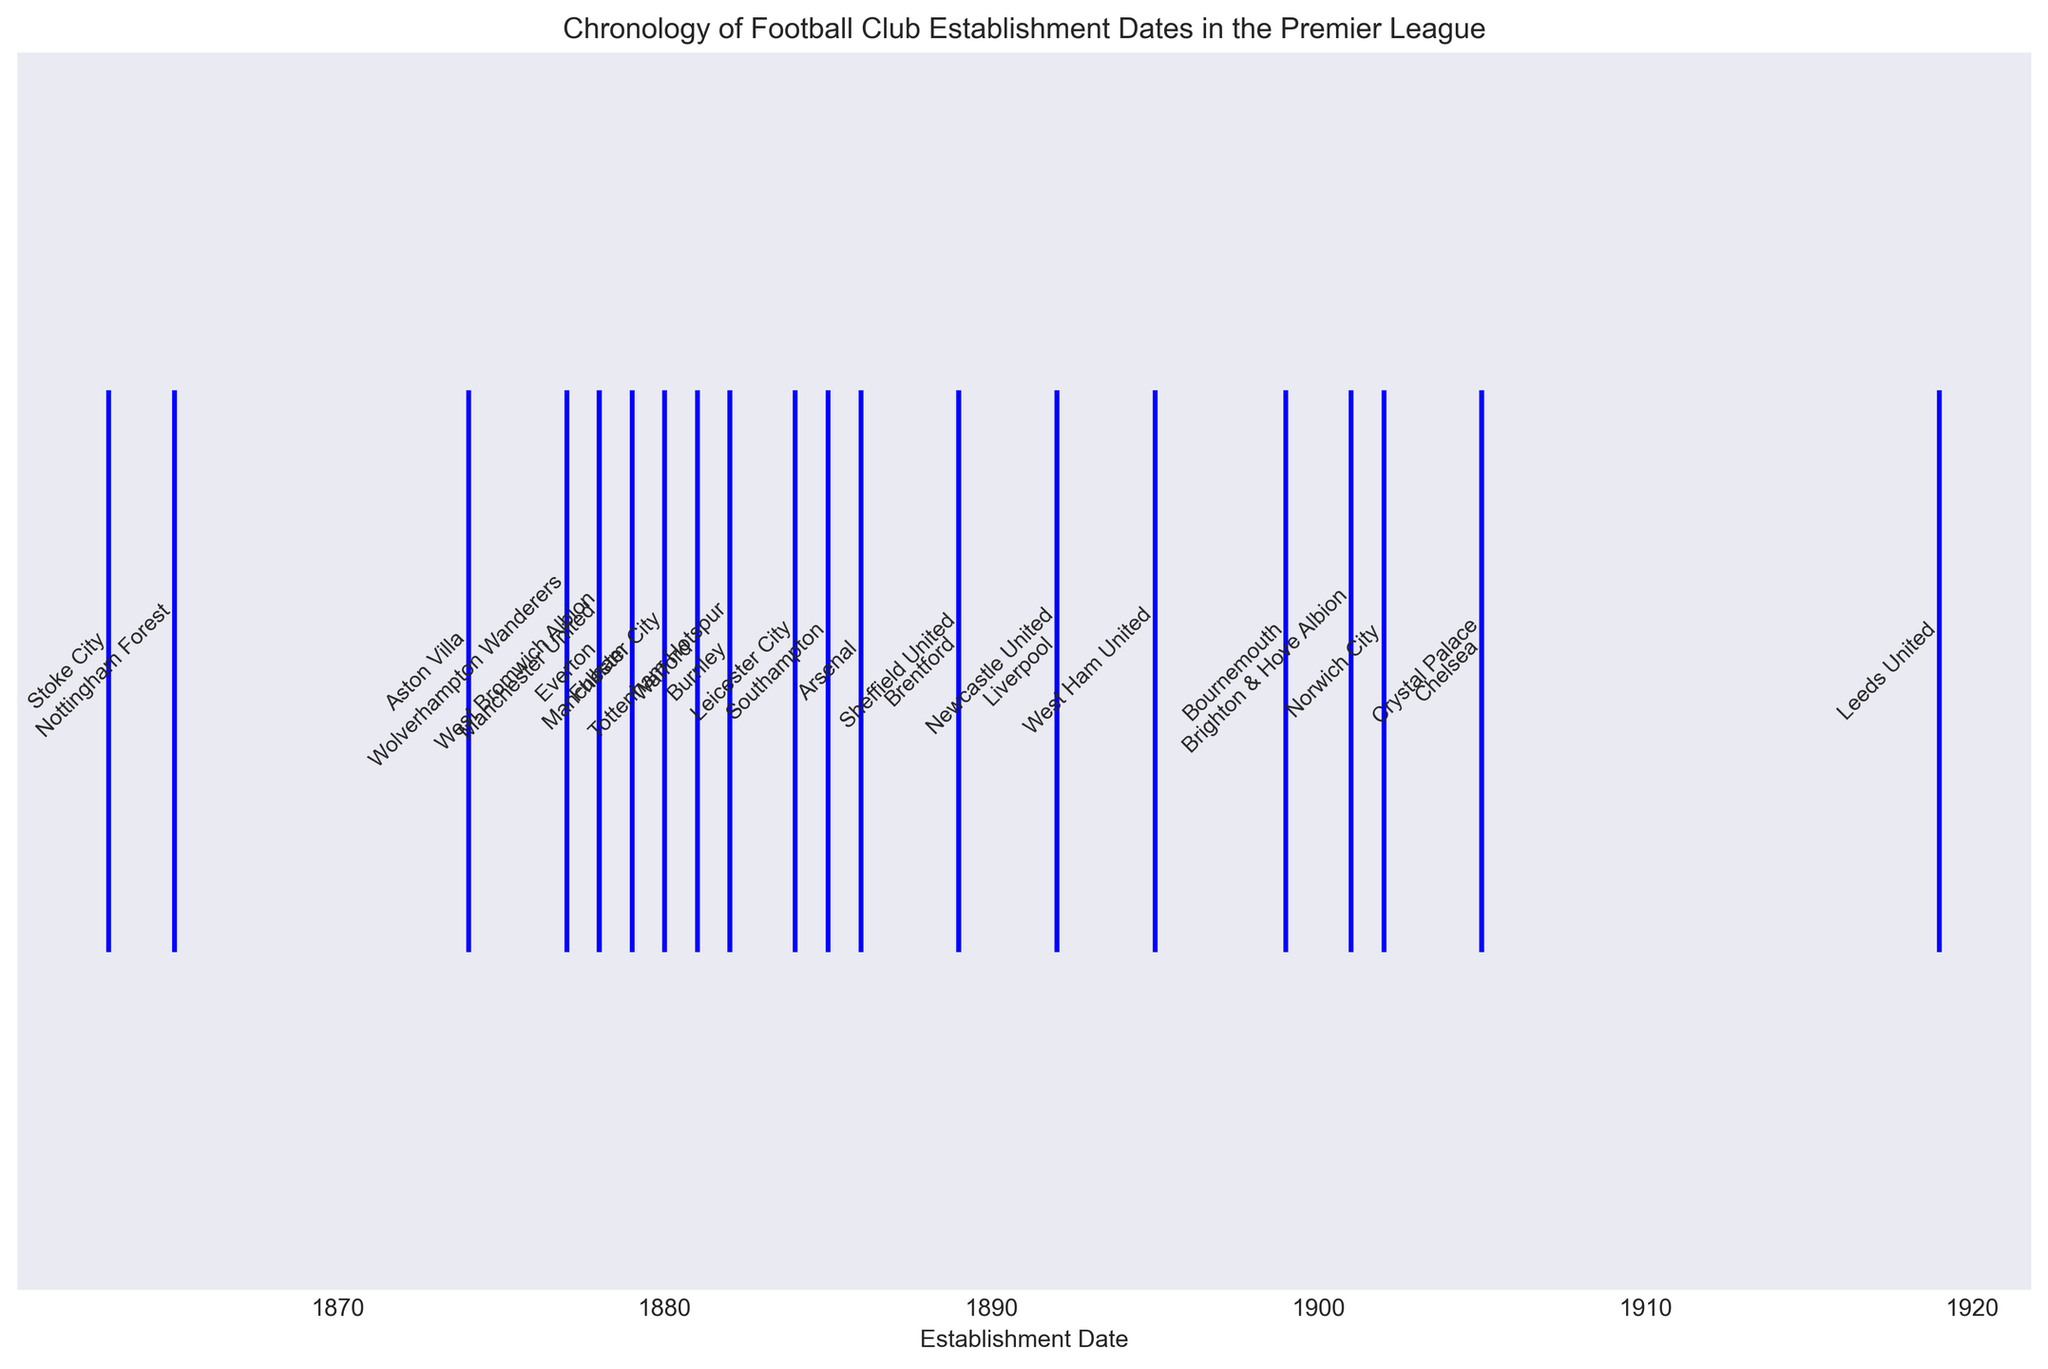Which club was established first? Look at the leftmost point on the timeline; the earliest date shown is 1863. The club established then is Stoke City.
Answer: Stoke City Which two clubs were established in the same year? Observe the points on the timeline and the annotations; both Liverpool and Newcastle United point to the year 1892.
Answer: Liverpool and Newcastle United Which club was established last according to the plot? Look at the rightmost point on the timeline; the latest date shown is 1919. The club established then is Leeds United.
Answer: Leeds United Which club was established earlier: Arsenal or Manchester City? Compare the annotated dates of Arsenal and Manchester City; Arsenal was established in 1886 and Manchester City in 1880.
Answer: Manchester City How many clubs were established in the 19th century (before 1900)? Count the clubs with establishment dates before 1900 in the annotations; they are Stoke City, Nottingham Forest, Aston Villa, Wolverhampton Wanderers, Everton, Fulham, Tottenham Hotspur, Manchester United, Burnley, West Bromwich Albion, Liverpool, Manchester City, Arsenal, Newcastle United, Sheffield United, Watford, Leicester City, West Ham United, and Bournemouth.
Answer: 19 What is the average establishment year of clubs founded in the 1880s? Identify clubs founded in the 1880s: Fulham (1881), Burnley (1882), Manchester City (1880), Watford (1881), Southampton (1885), Arsenal (1886), Sheffield United (1889), Brentford (1889); their average year is calculated as (1881+1882+1880+1881+1885+1886+1889+1889)/8 = 1884
Answer: 1884 Which of the following clubs was established earlier: Tottenham Hotspur or Burnley? Compare the annotated dates of Tottenham Hotspur and Burnley; both point to 1882. Therefore, they were established the same year.
Answer: Same year Which two clubs established in the 1890s are closest to each other on the timeline? Identify the clubs from the annotations: Liverpool and Newcastle United (1892), West Ham United (1895), and Bournemouth (1899); Liverpool and Newcastle United are closest to each other.
Answer: Liverpool and Newcastle United How many clubs were established after Chelsea? Identify clubs established after Chelsea (1905); Crystal Palace (1905), Norwich City (1902), Nottingham Forest (1865); three clubs were established after Chelsea.
Answer: 3 Which club's establishment date is closest to the year 1900? Observe the points around 1900 on the timeline; Norwich City was established in 1902, the closest to 1900.
Answer: Norwich City 